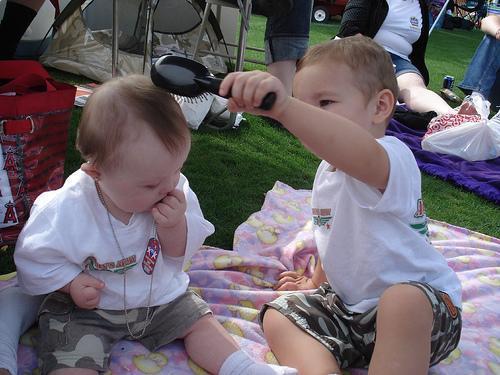How many children are there?
Give a very brief answer. 2. How many people are visible?
Give a very brief answer. 5. 